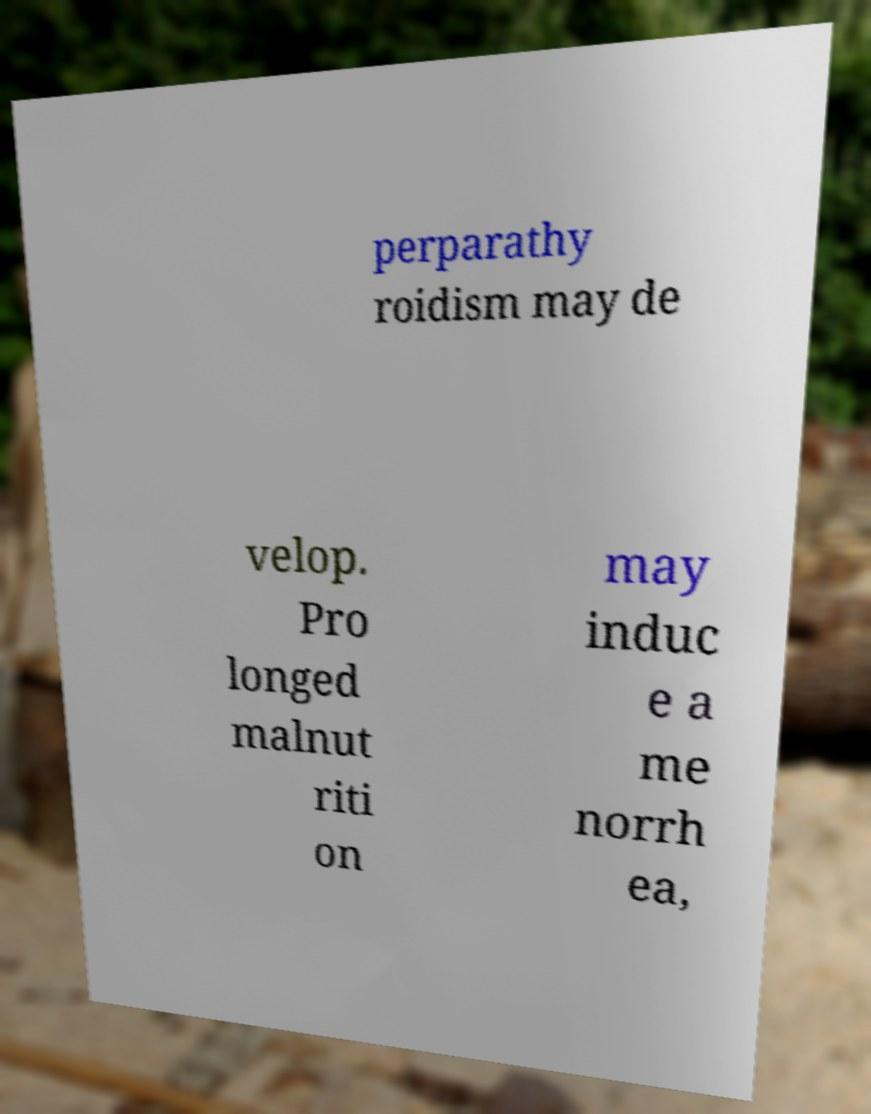Please identify and transcribe the text found in this image. perparathy roidism may de velop. Pro longed malnut riti on may induc e a me norrh ea, 